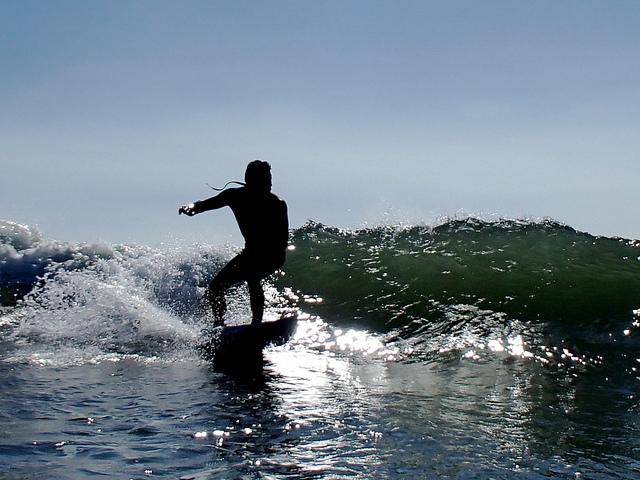Did he lose his surfboard?
Quick response, please. No. What is the man standing on?
Concise answer only. Surfboard. Is the wave big?
Quick response, please. Yes. Is he an expert or amateur?
Give a very brief answer. Expert. 